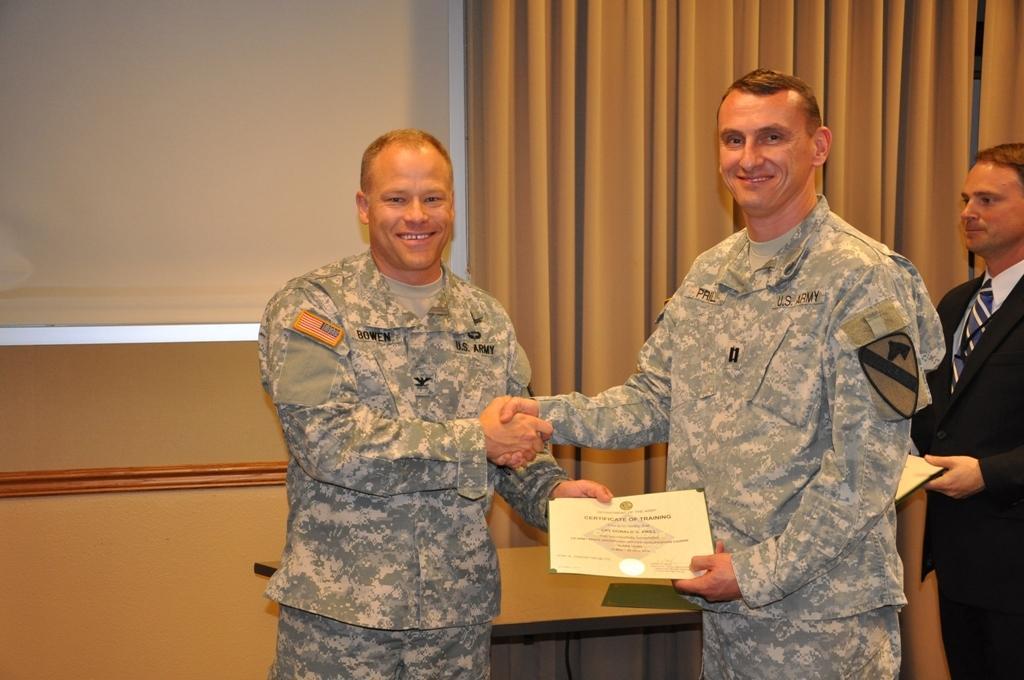In one or two sentences, can you explain what this image depicts? It seems to be the image is inside the room. In the image there three people standing and holding something on their hands. In background we can see a cream color curtain,white color screen and also a cream color wall and a table. 